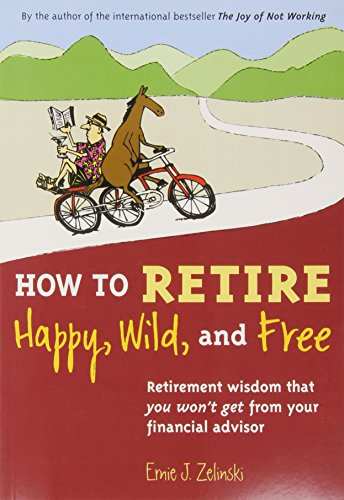What is the title of this book? The title of the book depicted in the image is 'How to Retire Happy, Wild, and Free: Retirement Wisdom That You Won't Get from Your Financial Advisor.' 